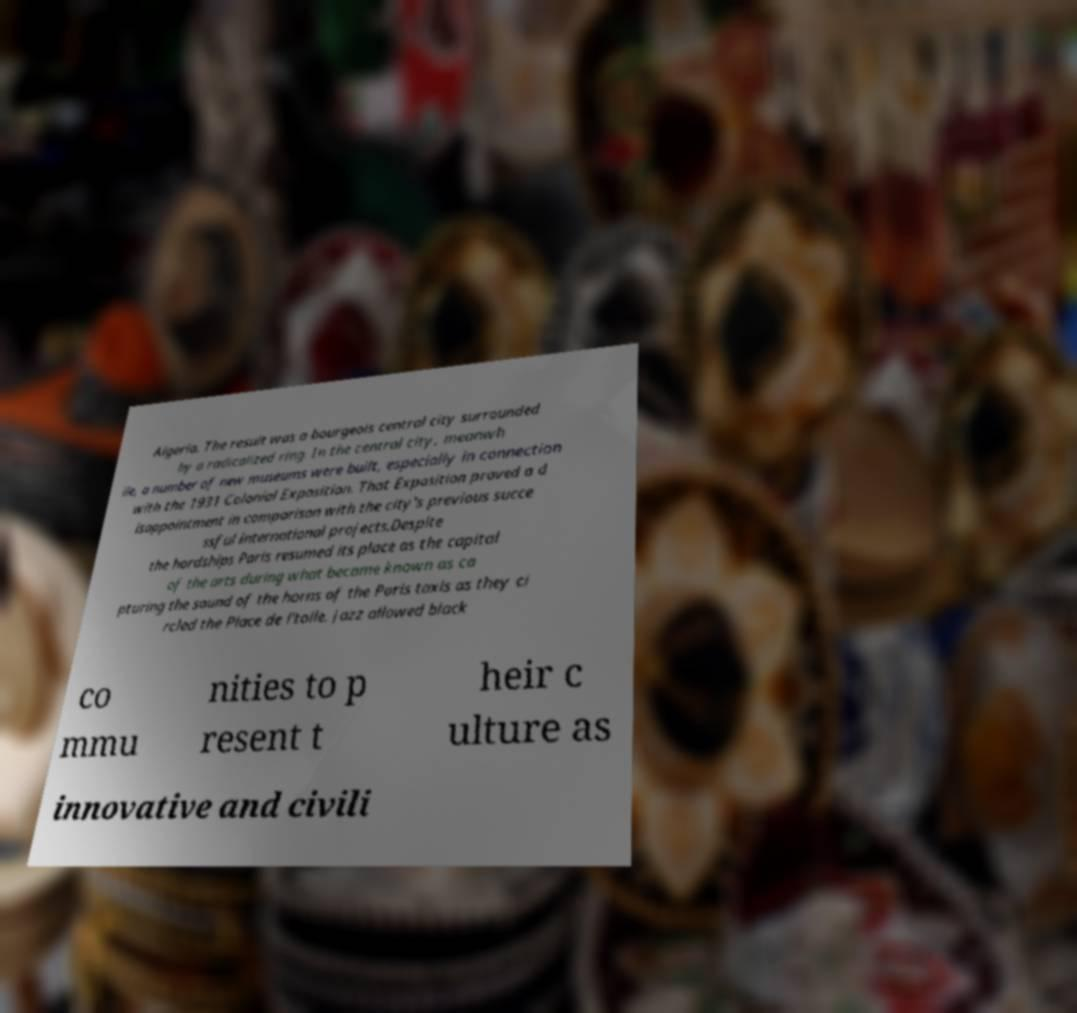Could you assist in decoding the text presented in this image and type it out clearly? Algeria. The result was a bourgeois central city surrounded by a radicalized ring. In the central city, meanwh ile, a number of new museums were built, especially in connection with the 1931 Colonial Exposition. That Exposition proved a d isappointment in comparison with the city's previous succe ssful international projects.Despite the hardships Paris resumed its place as the capital of the arts during what became known as ca pturing the sound of the horns of the Paris taxis as they ci rcled the Place de l'toile. Jazz allowed black co mmu nities to p resent t heir c ulture as innovative and civili 